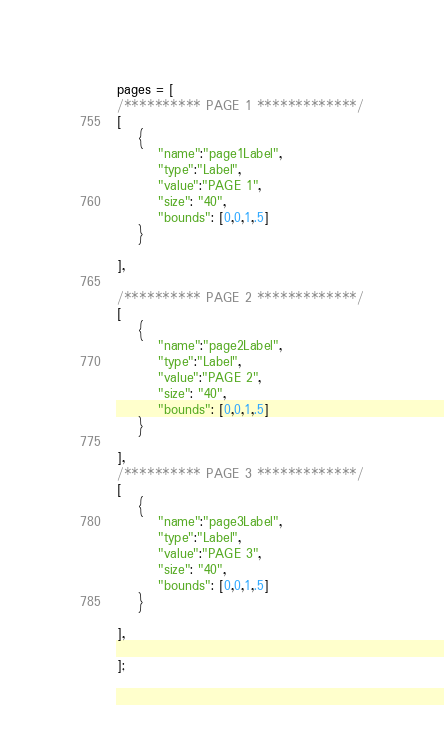Convert code to text. <code><loc_0><loc_0><loc_500><loc_500><_JavaScript_>
pages = [
/********** PAGE 1 *************/
[
    {
        "name":"page1Label",
        "type":"Label",
        "value":"PAGE 1",
        "size": "40",
        "bounds": [0,0,1,.5]
    }

],

/********** PAGE 2 *************/
[
    {
        "name":"page2Label",
        "type":"Label",
        "value":"PAGE 2",
        "size": "40",   
        "bounds": [0,0,1,.5]             
    }

],
/********** PAGE 3 *************/
[
    {
        "name":"page3Label",
        "type":"Label",
        "value":"PAGE 3",
        "size": "40",   
        "bounds": [0,0,1,.5]             
    }

],

];
</code> 